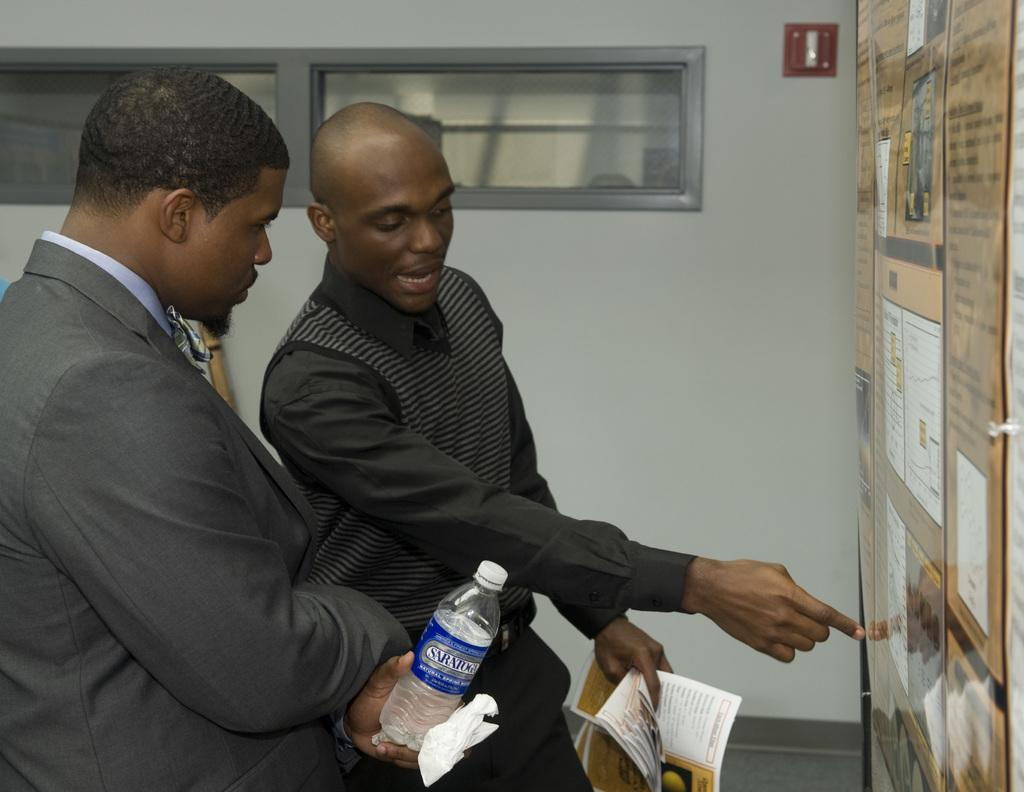How many people are in the image? There are two men in the image. What are the men doing in the image? The men are standing in the image. What objects are the men holding? The men are holding a bottle and a book in the image. Can you describe the background of the image? There are many pictures visible in the background of the image. Where is the scarecrow located in the image? There is no scarecrow present in the image. What type of chalk is being used to draw on the shelf in the image? There is no shelf or chalk present in the image. 